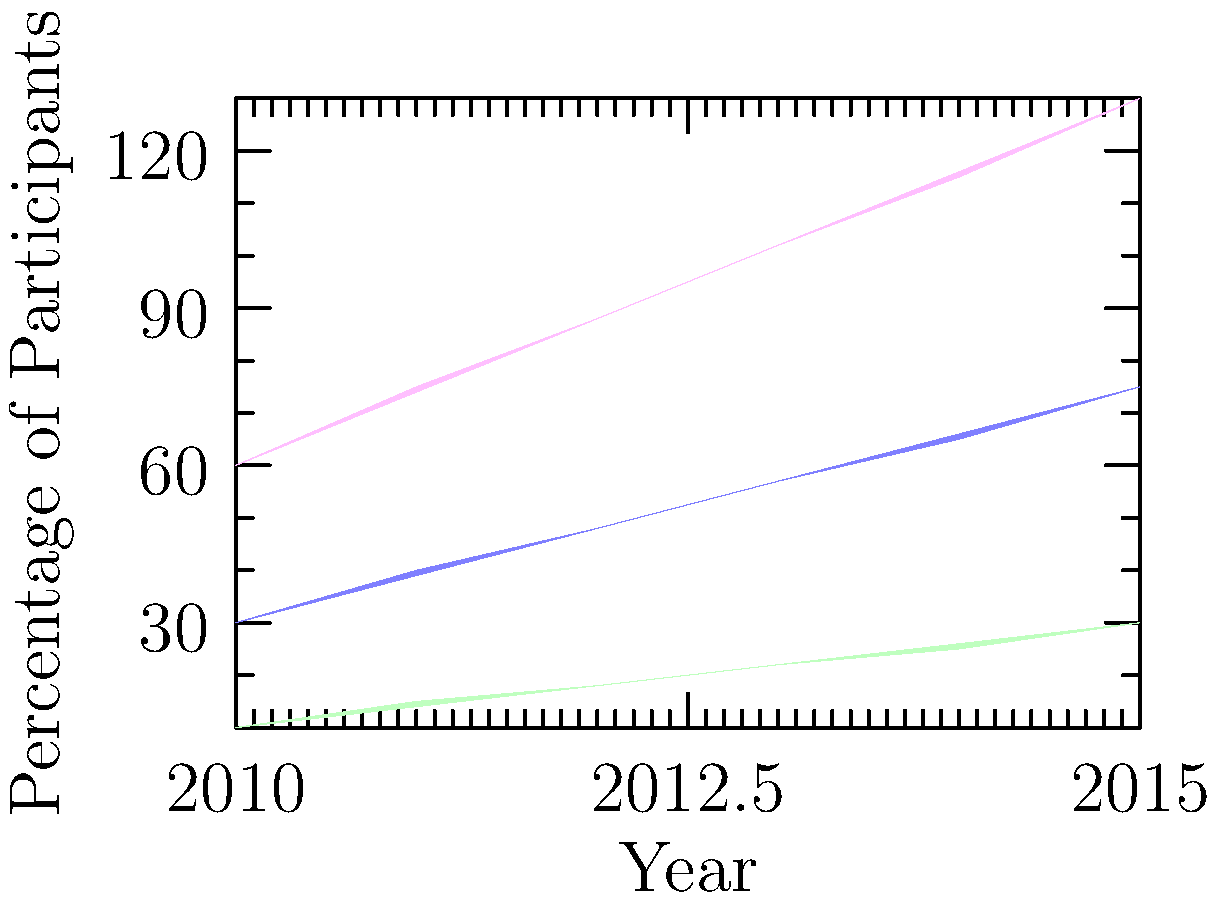Based on the stacked area chart depicting the effectiveness of a microfinance program from 2010 to 2015, what trend can be observed in the income levels of participants, and how might this inform community empowerment strategies in international development? To evaluate the effectiveness of the microfinance program and its implications for community empowerment strategies, let's analyze the chart step-by-step:

1. Income level distribution:
   - Low income (green): Increased from 10% to 30%
   - Medium income (blue): Increased from 20% to 45%
   - High income (pink): Increased from 30% to 55%

2. Overall trend:
   All income levels show a steady increase over the 5-year period, indicating positive outcomes for participants across all income categories.

3. Rate of growth:
   - Low income: Tripled (200% increase)
   - Medium income: More than doubled (125% increase)
   - High income: Nearly doubled (83% increase)

4. Relative growth:
   The low-income group shows the highest relative growth, suggesting the program is particularly effective in lifting participants out of poverty.

5. Income distribution:
   The chart shows a balanced growth across all income levels, maintaining a relatively even distribution throughout the period.

6. Implications for community empowerment:
   a) The program appears successful in improving economic conditions across all income levels.
   b) The significant growth in the low-income category suggests the program is effectively reaching and benefiting the most vulnerable populations.
   c) The balanced growth across income levels indicates the program supports economic mobility and reduces income inequality.

7. Strategies for international development:
   a) Continue and potentially expand the microfinance program, given its apparent success.
   b) Focus on understanding and replicating the factors contributing to the program's effectiveness, particularly for low-income participants.
   c) Consider implementing complementary programs to support the transition from low to medium, and medium to high-income categories.
   d) Use this data to advocate for similar programs in other communities or regions.
Answer: Positive trend across all income levels, with highest relative growth in low-income group, suggesting effective poverty reduction and balanced economic development. This informs strategies to expand and replicate the program while implementing complementary initiatives for continued economic mobility. 